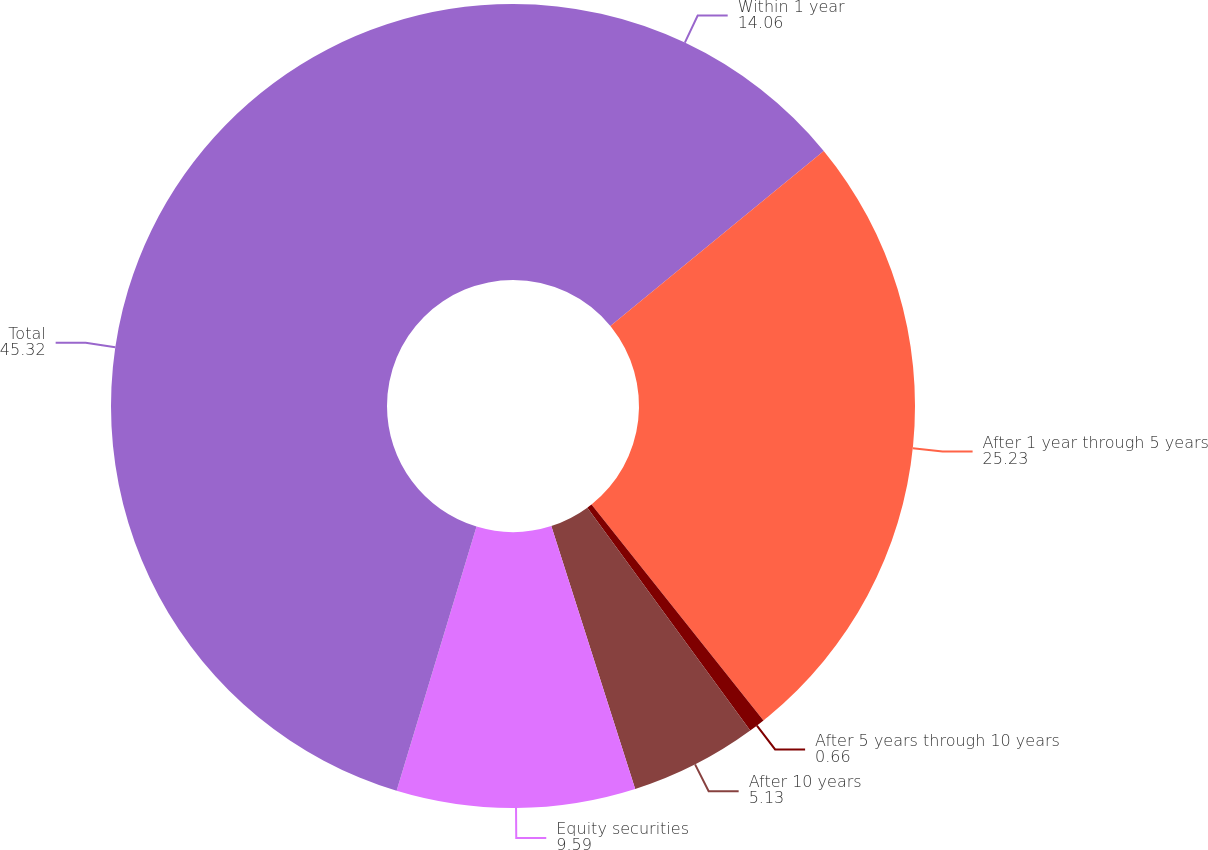Convert chart to OTSL. <chart><loc_0><loc_0><loc_500><loc_500><pie_chart><fcel>Within 1 year<fcel>After 1 year through 5 years<fcel>After 5 years through 10 years<fcel>After 10 years<fcel>Equity securities<fcel>Total<nl><fcel>14.06%<fcel>25.23%<fcel>0.66%<fcel>5.13%<fcel>9.59%<fcel>45.32%<nl></chart> 